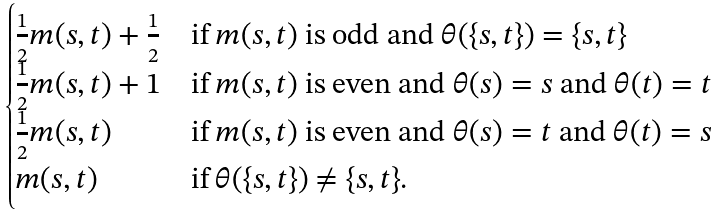Convert formula to latex. <formula><loc_0><loc_0><loc_500><loc_500>\begin{cases} \frac { 1 } { 2 } m ( s , t ) + \frac { 1 } { 2 } & \text {if $m(s,t)$ is odd and $\theta(\{s,t\})=\{s,t\}$} \\ \frac { 1 } { 2 } m ( s , t ) + 1 & \text {if $m(s,t)$ is even and $\theta(s) = s$ and $\theta(t)=t$} \\ \frac { 1 } { 2 } m ( s , t ) & \text {if $m(s,t)$ is even and $\theta(s)=t$ and $\theta(t)=s$} \\ m ( s , t ) & \text {if $\theta(\{s,t\})\neq \{s,t\}$} . \end{cases}</formula> 